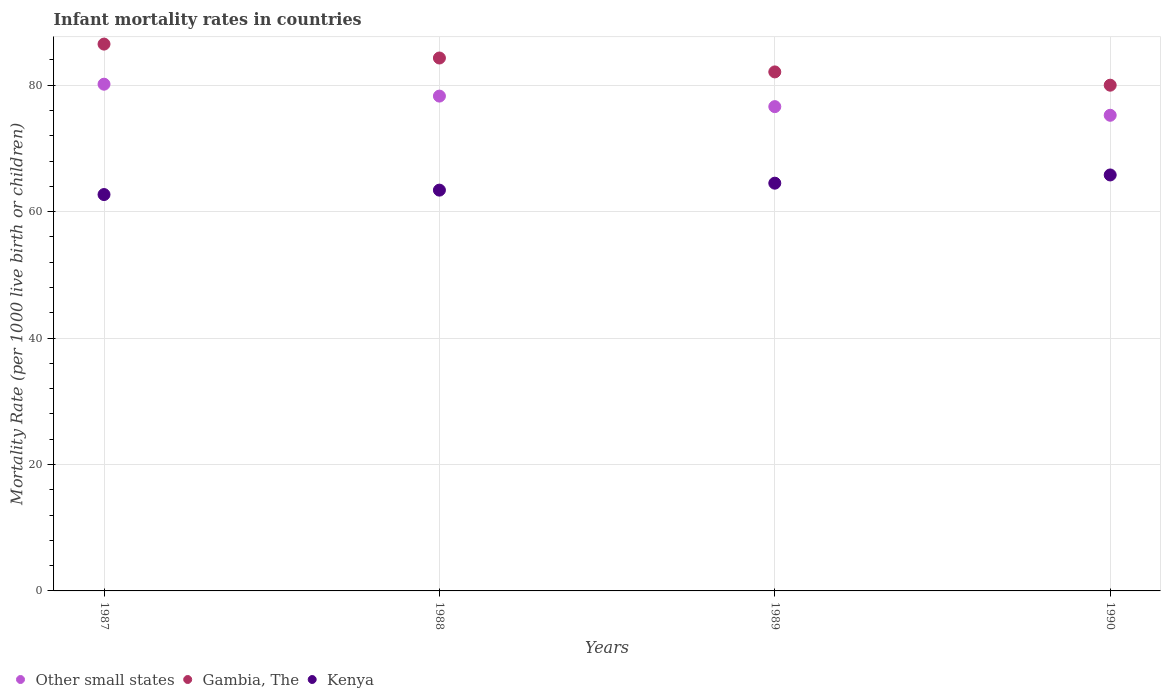How many different coloured dotlines are there?
Keep it short and to the point. 3. Is the number of dotlines equal to the number of legend labels?
Your response must be concise. Yes. What is the infant mortality rate in Kenya in 1987?
Give a very brief answer. 62.7. Across all years, what is the maximum infant mortality rate in Gambia, The?
Make the answer very short. 86.5. Across all years, what is the minimum infant mortality rate in Gambia, The?
Give a very brief answer. 80. In which year was the infant mortality rate in Kenya maximum?
Make the answer very short. 1990. In which year was the infant mortality rate in Other small states minimum?
Your answer should be compact. 1990. What is the total infant mortality rate in Gambia, The in the graph?
Your answer should be very brief. 332.9. What is the difference between the infant mortality rate in Other small states in 1989 and that in 1990?
Make the answer very short. 1.37. What is the difference between the infant mortality rate in Gambia, The in 1989 and the infant mortality rate in Other small states in 1990?
Your answer should be very brief. 6.86. What is the average infant mortality rate in Other small states per year?
Your answer should be very brief. 77.57. In the year 1989, what is the difference between the infant mortality rate in Other small states and infant mortality rate in Kenya?
Give a very brief answer. 12.11. In how many years, is the infant mortality rate in Other small states greater than 40?
Your response must be concise. 4. What is the ratio of the infant mortality rate in Kenya in 1988 to that in 1990?
Offer a terse response. 0.96. Is the infant mortality rate in Other small states in 1989 less than that in 1990?
Provide a short and direct response. No. What is the difference between the highest and the second highest infant mortality rate in Other small states?
Make the answer very short. 1.88. What is the difference between the highest and the lowest infant mortality rate in Other small states?
Give a very brief answer. 4.92. In how many years, is the infant mortality rate in Other small states greater than the average infant mortality rate in Other small states taken over all years?
Ensure brevity in your answer.  2. Is it the case that in every year, the sum of the infant mortality rate in Kenya and infant mortality rate in Other small states  is greater than the infant mortality rate in Gambia, The?
Offer a very short reply. Yes. Is the infant mortality rate in Kenya strictly greater than the infant mortality rate in Gambia, The over the years?
Your response must be concise. No. How many dotlines are there?
Offer a terse response. 3. Are the values on the major ticks of Y-axis written in scientific E-notation?
Your answer should be very brief. No. Does the graph contain grids?
Ensure brevity in your answer.  Yes. Where does the legend appear in the graph?
Your response must be concise. Bottom left. How many legend labels are there?
Give a very brief answer. 3. How are the legend labels stacked?
Provide a succinct answer. Horizontal. What is the title of the graph?
Make the answer very short. Infant mortality rates in countries. Does "Croatia" appear as one of the legend labels in the graph?
Offer a terse response. No. What is the label or title of the X-axis?
Provide a short and direct response. Years. What is the label or title of the Y-axis?
Provide a short and direct response. Mortality Rate (per 1000 live birth or children). What is the Mortality Rate (per 1000 live birth or children) of Other small states in 1987?
Offer a terse response. 80.16. What is the Mortality Rate (per 1000 live birth or children) of Gambia, The in 1987?
Keep it short and to the point. 86.5. What is the Mortality Rate (per 1000 live birth or children) of Kenya in 1987?
Provide a succinct answer. 62.7. What is the Mortality Rate (per 1000 live birth or children) in Other small states in 1988?
Offer a very short reply. 78.27. What is the Mortality Rate (per 1000 live birth or children) in Gambia, The in 1988?
Your answer should be very brief. 84.3. What is the Mortality Rate (per 1000 live birth or children) in Kenya in 1988?
Give a very brief answer. 63.4. What is the Mortality Rate (per 1000 live birth or children) in Other small states in 1989?
Your response must be concise. 76.61. What is the Mortality Rate (per 1000 live birth or children) in Gambia, The in 1989?
Your answer should be compact. 82.1. What is the Mortality Rate (per 1000 live birth or children) in Kenya in 1989?
Keep it short and to the point. 64.5. What is the Mortality Rate (per 1000 live birth or children) of Other small states in 1990?
Give a very brief answer. 75.24. What is the Mortality Rate (per 1000 live birth or children) of Gambia, The in 1990?
Your response must be concise. 80. What is the Mortality Rate (per 1000 live birth or children) of Kenya in 1990?
Make the answer very short. 65.8. Across all years, what is the maximum Mortality Rate (per 1000 live birth or children) in Other small states?
Your answer should be very brief. 80.16. Across all years, what is the maximum Mortality Rate (per 1000 live birth or children) in Gambia, The?
Keep it short and to the point. 86.5. Across all years, what is the maximum Mortality Rate (per 1000 live birth or children) of Kenya?
Your answer should be compact. 65.8. Across all years, what is the minimum Mortality Rate (per 1000 live birth or children) in Other small states?
Your answer should be compact. 75.24. Across all years, what is the minimum Mortality Rate (per 1000 live birth or children) of Kenya?
Keep it short and to the point. 62.7. What is the total Mortality Rate (per 1000 live birth or children) of Other small states in the graph?
Provide a short and direct response. 310.28. What is the total Mortality Rate (per 1000 live birth or children) in Gambia, The in the graph?
Ensure brevity in your answer.  332.9. What is the total Mortality Rate (per 1000 live birth or children) of Kenya in the graph?
Offer a terse response. 256.4. What is the difference between the Mortality Rate (per 1000 live birth or children) in Other small states in 1987 and that in 1988?
Your answer should be very brief. 1.88. What is the difference between the Mortality Rate (per 1000 live birth or children) in Gambia, The in 1987 and that in 1988?
Your answer should be very brief. 2.2. What is the difference between the Mortality Rate (per 1000 live birth or children) of Other small states in 1987 and that in 1989?
Make the answer very short. 3.55. What is the difference between the Mortality Rate (per 1000 live birth or children) of Gambia, The in 1987 and that in 1989?
Provide a succinct answer. 4.4. What is the difference between the Mortality Rate (per 1000 live birth or children) of Other small states in 1987 and that in 1990?
Offer a terse response. 4.92. What is the difference between the Mortality Rate (per 1000 live birth or children) in Gambia, The in 1987 and that in 1990?
Offer a terse response. 6.5. What is the difference between the Mortality Rate (per 1000 live birth or children) of Kenya in 1987 and that in 1990?
Offer a terse response. -3.1. What is the difference between the Mortality Rate (per 1000 live birth or children) in Other small states in 1988 and that in 1989?
Keep it short and to the point. 1.67. What is the difference between the Mortality Rate (per 1000 live birth or children) of Gambia, The in 1988 and that in 1989?
Offer a very short reply. 2.2. What is the difference between the Mortality Rate (per 1000 live birth or children) in Kenya in 1988 and that in 1989?
Your answer should be very brief. -1.1. What is the difference between the Mortality Rate (per 1000 live birth or children) of Other small states in 1988 and that in 1990?
Provide a short and direct response. 3.03. What is the difference between the Mortality Rate (per 1000 live birth or children) of Gambia, The in 1988 and that in 1990?
Ensure brevity in your answer.  4.3. What is the difference between the Mortality Rate (per 1000 live birth or children) in Other small states in 1989 and that in 1990?
Provide a succinct answer. 1.37. What is the difference between the Mortality Rate (per 1000 live birth or children) in Gambia, The in 1989 and that in 1990?
Your response must be concise. 2.1. What is the difference between the Mortality Rate (per 1000 live birth or children) in Kenya in 1989 and that in 1990?
Keep it short and to the point. -1.3. What is the difference between the Mortality Rate (per 1000 live birth or children) of Other small states in 1987 and the Mortality Rate (per 1000 live birth or children) of Gambia, The in 1988?
Keep it short and to the point. -4.14. What is the difference between the Mortality Rate (per 1000 live birth or children) in Other small states in 1987 and the Mortality Rate (per 1000 live birth or children) in Kenya in 1988?
Offer a terse response. 16.76. What is the difference between the Mortality Rate (per 1000 live birth or children) in Gambia, The in 1987 and the Mortality Rate (per 1000 live birth or children) in Kenya in 1988?
Your response must be concise. 23.1. What is the difference between the Mortality Rate (per 1000 live birth or children) in Other small states in 1987 and the Mortality Rate (per 1000 live birth or children) in Gambia, The in 1989?
Give a very brief answer. -1.94. What is the difference between the Mortality Rate (per 1000 live birth or children) in Other small states in 1987 and the Mortality Rate (per 1000 live birth or children) in Kenya in 1989?
Offer a very short reply. 15.66. What is the difference between the Mortality Rate (per 1000 live birth or children) of Gambia, The in 1987 and the Mortality Rate (per 1000 live birth or children) of Kenya in 1989?
Offer a very short reply. 22. What is the difference between the Mortality Rate (per 1000 live birth or children) of Other small states in 1987 and the Mortality Rate (per 1000 live birth or children) of Gambia, The in 1990?
Give a very brief answer. 0.16. What is the difference between the Mortality Rate (per 1000 live birth or children) in Other small states in 1987 and the Mortality Rate (per 1000 live birth or children) in Kenya in 1990?
Offer a very short reply. 14.36. What is the difference between the Mortality Rate (per 1000 live birth or children) in Gambia, The in 1987 and the Mortality Rate (per 1000 live birth or children) in Kenya in 1990?
Keep it short and to the point. 20.7. What is the difference between the Mortality Rate (per 1000 live birth or children) in Other small states in 1988 and the Mortality Rate (per 1000 live birth or children) in Gambia, The in 1989?
Provide a succinct answer. -3.83. What is the difference between the Mortality Rate (per 1000 live birth or children) of Other small states in 1988 and the Mortality Rate (per 1000 live birth or children) of Kenya in 1989?
Your response must be concise. 13.77. What is the difference between the Mortality Rate (per 1000 live birth or children) in Gambia, The in 1988 and the Mortality Rate (per 1000 live birth or children) in Kenya in 1989?
Ensure brevity in your answer.  19.8. What is the difference between the Mortality Rate (per 1000 live birth or children) of Other small states in 1988 and the Mortality Rate (per 1000 live birth or children) of Gambia, The in 1990?
Provide a short and direct response. -1.73. What is the difference between the Mortality Rate (per 1000 live birth or children) of Other small states in 1988 and the Mortality Rate (per 1000 live birth or children) of Kenya in 1990?
Ensure brevity in your answer.  12.47. What is the difference between the Mortality Rate (per 1000 live birth or children) in Other small states in 1989 and the Mortality Rate (per 1000 live birth or children) in Gambia, The in 1990?
Provide a succinct answer. -3.39. What is the difference between the Mortality Rate (per 1000 live birth or children) in Other small states in 1989 and the Mortality Rate (per 1000 live birth or children) in Kenya in 1990?
Ensure brevity in your answer.  10.81. What is the difference between the Mortality Rate (per 1000 live birth or children) in Gambia, The in 1989 and the Mortality Rate (per 1000 live birth or children) in Kenya in 1990?
Give a very brief answer. 16.3. What is the average Mortality Rate (per 1000 live birth or children) of Other small states per year?
Your answer should be compact. 77.57. What is the average Mortality Rate (per 1000 live birth or children) in Gambia, The per year?
Offer a terse response. 83.22. What is the average Mortality Rate (per 1000 live birth or children) of Kenya per year?
Offer a very short reply. 64.1. In the year 1987, what is the difference between the Mortality Rate (per 1000 live birth or children) of Other small states and Mortality Rate (per 1000 live birth or children) of Gambia, The?
Offer a very short reply. -6.34. In the year 1987, what is the difference between the Mortality Rate (per 1000 live birth or children) of Other small states and Mortality Rate (per 1000 live birth or children) of Kenya?
Ensure brevity in your answer.  17.46. In the year 1987, what is the difference between the Mortality Rate (per 1000 live birth or children) of Gambia, The and Mortality Rate (per 1000 live birth or children) of Kenya?
Your response must be concise. 23.8. In the year 1988, what is the difference between the Mortality Rate (per 1000 live birth or children) of Other small states and Mortality Rate (per 1000 live birth or children) of Gambia, The?
Make the answer very short. -6.03. In the year 1988, what is the difference between the Mortality Rate (per 1000 live birth or children) in Other small states and Mortality Rate (per 1000 live birth or children) in Kenya?
Provide a succinct answer. 14.87. In the year 1988, what is the difference between the Mortality Rate (per 1000 live birth or children) in Gambia, The and Mortality Rate (per 1000 live birth or children) in Kenya?
Your response must be concise. 20.9. In the year 1989, what is the difference between the Mortality Rate (per 1000 live birth or children) in Other small states and Mortality Rate (per 1000 live birth or children) in Gambia, The?
Offer a terse response. -5.49. In the year 1989, what is the difference between the Mortality Rate (per 1000 live birth or children) in Other small states and Mortality Rate (per 1000 live birth or children) in Kenya?
Give a very brief answer. 12.11. In the year 1989, what is the difference between the Mortality Rate (per 1000 live birth or children) in Gambia, The and Mortality Rate (per 1000 live birth or children) in Kenya?
Make the answer very short. 17.6. In the year 1990, what is the difference between the Mortality Rate (per 1000 live birth or children) in Other small states and Mortality Rate (per 1000 live birth or children) in Gambia, The?
Your answer should be very brief. -4.76. In the year 1990, what is the difference between the Mortality Rate (per 1000 live birth or children) of Other small states and Mortality Rate (per 1000 live birth or children) of Kenya?
Make the answer very short. 9.44. In the year 1990, what is the difference between the Mortality Rate (per 1000 live birth or children) in Gambia, The and Mortality Rate (per 1000 live birth or children) in Kenya?
Provide a short and direct response. 14.2. What is the ratio of the Mortality Rate (per 1000 live birth or children) of Other small states in 1987 to that in 1988?
Offer a very short reply. 1.02. What is the ratio of the Mortality Rate (per 1000 live birth or children) of Gambia, The in 1987 to that in 1988?
Offer a terse response. 1.03. What is the ratio of the Mortality Rate (per 1000 live birth or children) in Kenya in 1987 to that in 1988?
Give a very brief answer. 0.99. What is the ratio of the Mortality Rate (per 1000 live birth or children) in Other small states in 1987 to that in 1989?
Provide a succinct answer. 1.05. What is the ratio of the Mortality Rate (per 1000 live birth or children) of Gambia, The in 1987 to that in 1989?
Ensure brevity in your answer.  1.05. What is the ratio of the Mortality Rate (per 1000 live birth or children) in Kenya in 1987 to that in 1989?
Give a very brief answer. 0.97. What is the ratio of the Mortality Rate (per 1000 live birth or children) of Other small states in 1987 to that in 1990?
Ensure brevity in your answer.  1.07. What is the ratio of the Mortality Rate (per 1000 live birth or children) in Gambia, The in 1987 to that in 1990?
Your answer should be compact. 1.08. What is the ratio of the Mortality Rate (per 1000 live birth or children) of Kenya in 1987 to that in 1990?
Provide a succinct answer. 0.95. What is the ratio of the Mortality Rate (per 1000 live birth or children) in Other small states in 1988 to that in 1989?
Ensure brevity in your answer.  1.02. What is the ratio of the Mortality Rate (per 1000 live birth or children) in Gambia, The in 1988 to that in 1989?
Your answer should be very brief. 1.03. What is the ratio of the Mortality Rate (per 1000 live birth or children) of Kenya in 1988 to that in 1989?
Provide a short and direct response. 0.98. What is the ratio of the Mortality Rate (per 1000 live birth or children) in Other small states in 1988 to that in 1990?
Provide a short and direct response. 1.04. What is the ratio of the Mortality Rate (per 1000 live birth or children) in Gambia, The in 1988 to that in 1990?
Provide a succinct answer. 1.05. What is the ratio of the Mortality Rate (per 1000 live birth or children) in Kenya in 1988 to that in 1990?
Ensure brevity in your answer.  0.96. What is the ratio of the Mortality Rate (per 1000 live birth or children) of Other small states in 1989 to that in 1990?
Provide a succinct answer. 1.02. What is the ratio of the Mortality Rate (per 1000 live birth or children) of Gambia, The in 1989 to that in 1990?
Keep it short and to the point. 1.03. What is the ratio of the Mortality Rate (per 1000 live birth or children) of Kenya in 1989 to that in 1990?
Ensure brevity in your answer.  0.98. What is the difference between the highest and the second highest Mortality Rate (per 1000 live birth or children) in Other small states?
Offer a very short reply. 1.88. What is the difference between the highest and the second highest Mortality Rate (per 1000 live birth or children) in Gambia, The?
Offer a terse response. 2.2. What is the difference between the highest and the second highest Mortality Rate (per 1000 live birth or children) in Kenya?
Your response must be concise. 1.3. What is the difference between the highest and the lowest Mortality Rate (per 1000 live birth or children) in Other small states?
Make the answer very short. 4.92. What is the difference between the highest and the lowest Mortality Rate (per 1000 live birth or children) in Gambia, The?
Offer a terse response. 6.5. What is the difference between the highest and the lowest Mortality Rate (per 1000 live birth or children) of Kenya?
Make the answer very short. 3.1. 